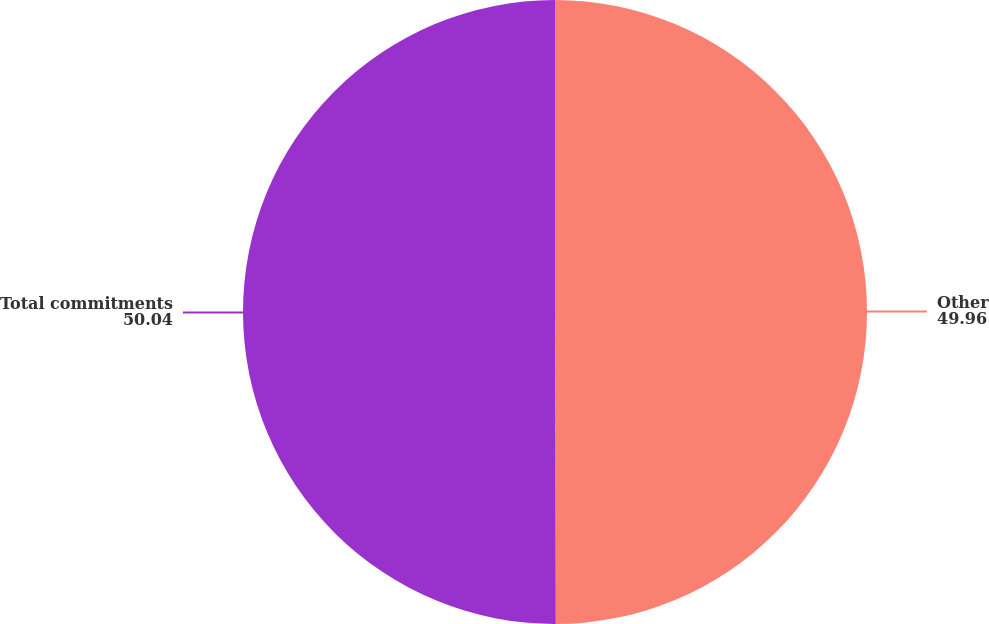Convert chart. <chart><loc_0><loc_0><loc_500><loc_500><pie_chart><fcel>Other<fcel>Total commitments<nl><fcel>49.96%<fcel>50.04%<nl></chart> 